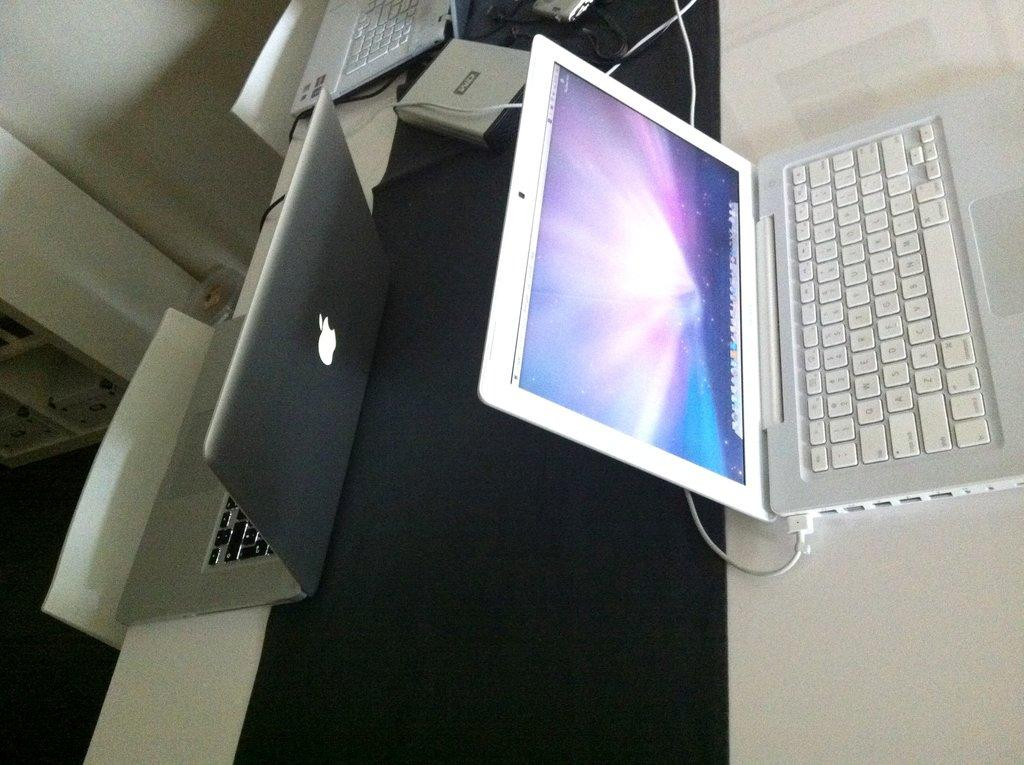What piece of furniture is present in the image? There is a table in the image. What electronic devices are on the table? There are laptops on the table. What type of seating is available near the table? There are chairs beside the table. How many women are sitting on the base of the table in the image? There are no women or base present in the image. 